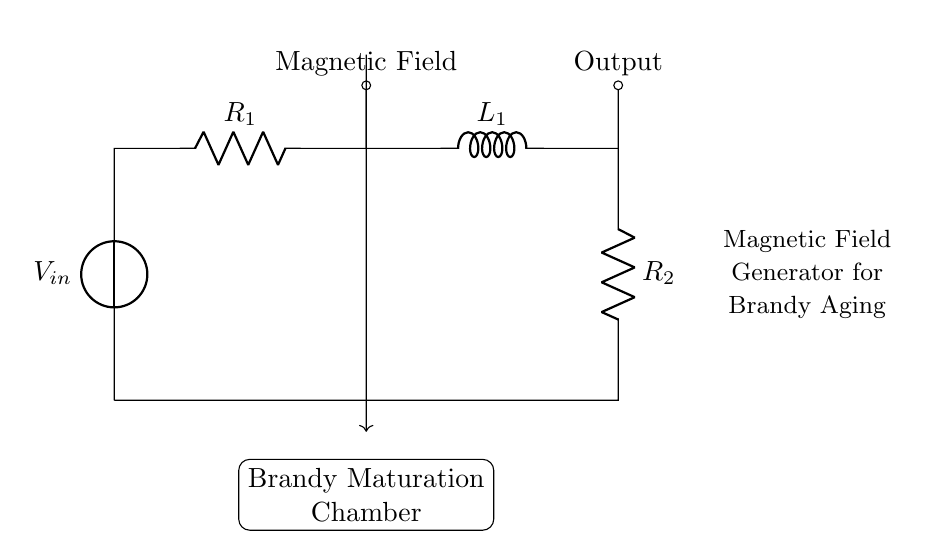What is the name of the first component? The first component is a voltage source, labeled as V in the circuit diagram, providing the input voltage required for the operation of the circuit.
Answer: Voltage source What type of circuit is this? This is an RL circuit, characterized by the presence of resistors and an inductor which are used to manage current flow and magnetic fields.
Answer: RL circuit What is the purpose of the inductor in this circuit? The inductor's purpose is to store energy in a magnetic field when current flows through it, which is essential for influencing the magnetic field used in brandy maturation.
Answer: Store energy How many resistors are there in the circuit? There are two resistors in the circuit, labeled as R1 and R2, which help control the current within the RL circuit.
Answer: Two What is connected to the output of the circuit? The output of the circuit is connected to a point labeled as "Output," representing where the influence of the magnetic field is applied for brandy aging.
Answer: Magnetic field What is the role of the brandy maturation chamber in this circuit? The brandy maturation chamber is where the influenced magnetic field will interact with the brandy, affecting its aging process through the magnetic effects generated by the RL circuit.
Answer: Aging process How does the circuit generate a magnetic field? The circuit generates a magnetic field through the inductor when current flows, creating a magnetic field that can be utilized in the brandy maturation process.
Answer: Current flow 